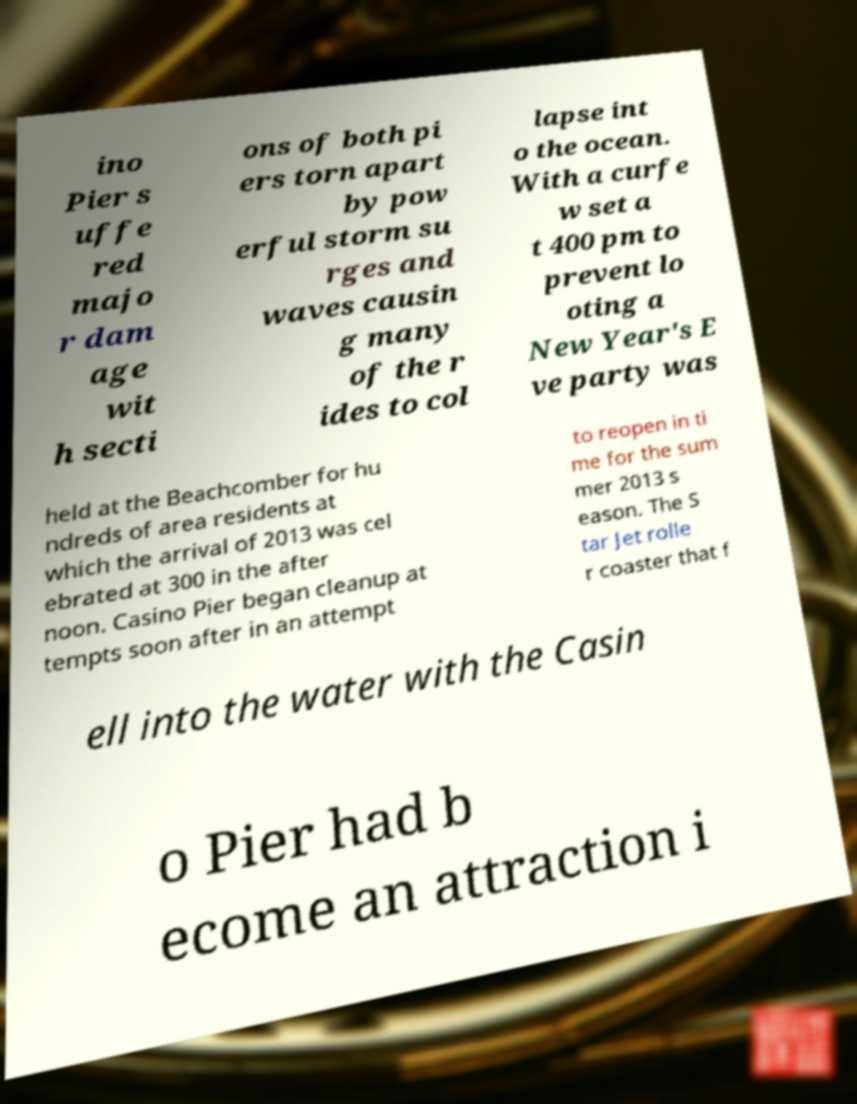Please identify and transcribe the text found in this image. ino Pier s uffe red majo r dam age wit h secti ons of both pi ers torn apart by pow erful storm su rges and waves causin g many of the r ides to col lapse int o the ocean. With a curfe w set a t 400 pm to prevent lo oting a New Year's E ve party was held at the Beachcomber for hu ndreds of area residents at which the arrival of 2013 was cel ebrated at 300 in the after noon. Casino Pier began cleanup at tempts soon after in an attempt to reopen in ti me for the sum mer 2013 s eason. The S tar Jet rolle r coaster that f ell into the water with the Casin o Pier had b ecome an attraction i 